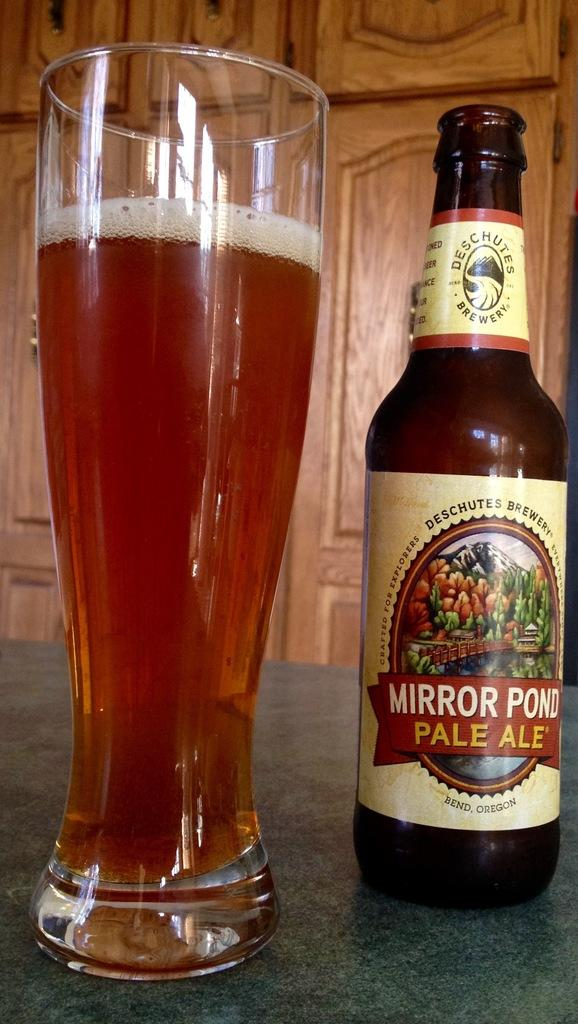<image>
Create a compact narrative representing the image presented. Bottle of Mirror Pond Pale Ale from Bend, Oregon 